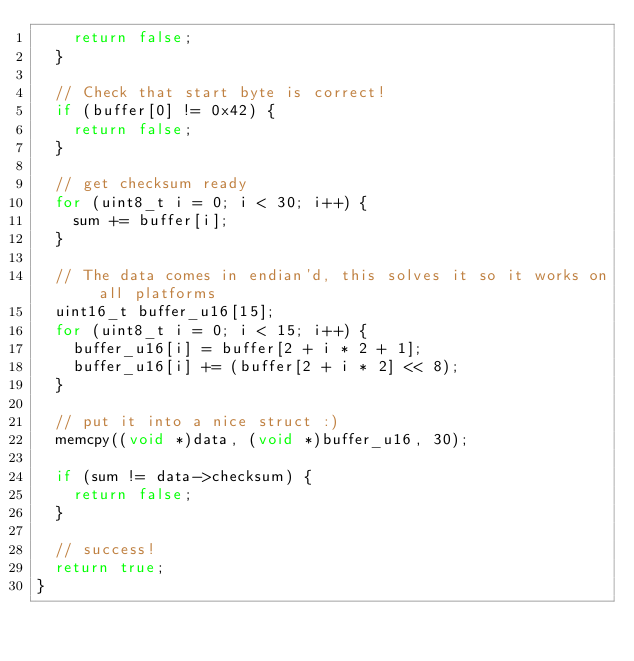<code> <loc_0><loc_0><loc_500><loc_500><_C++_>    return false;
  }

  // Check that start byte is correct!
  if (buffer[0] != 0x42) {
    return false;
  }

  // get checksum ready
  for (uint8_t i = 0; i < 30; i++) {
    sum += buffer[i];
  }

  // The data comes in endian'd, this solves it so it works on all platforms
  uint16_t buffer_u16[15];
  for (uint8_t i = 0; i < 15; i++) {
    buffer_u16[i] = buffer[2 + i * 2 + 1];
    buffer_u16[i] += (buffer[2 + i * 2] << 8);
  }

  // put it into a nice struct :)
  memcpy((void *)data, (void *)buffer_u16, 30);

  if (sum != data->checksum) {
    return false;
  }

  // success!
  return true;
}
</code> 